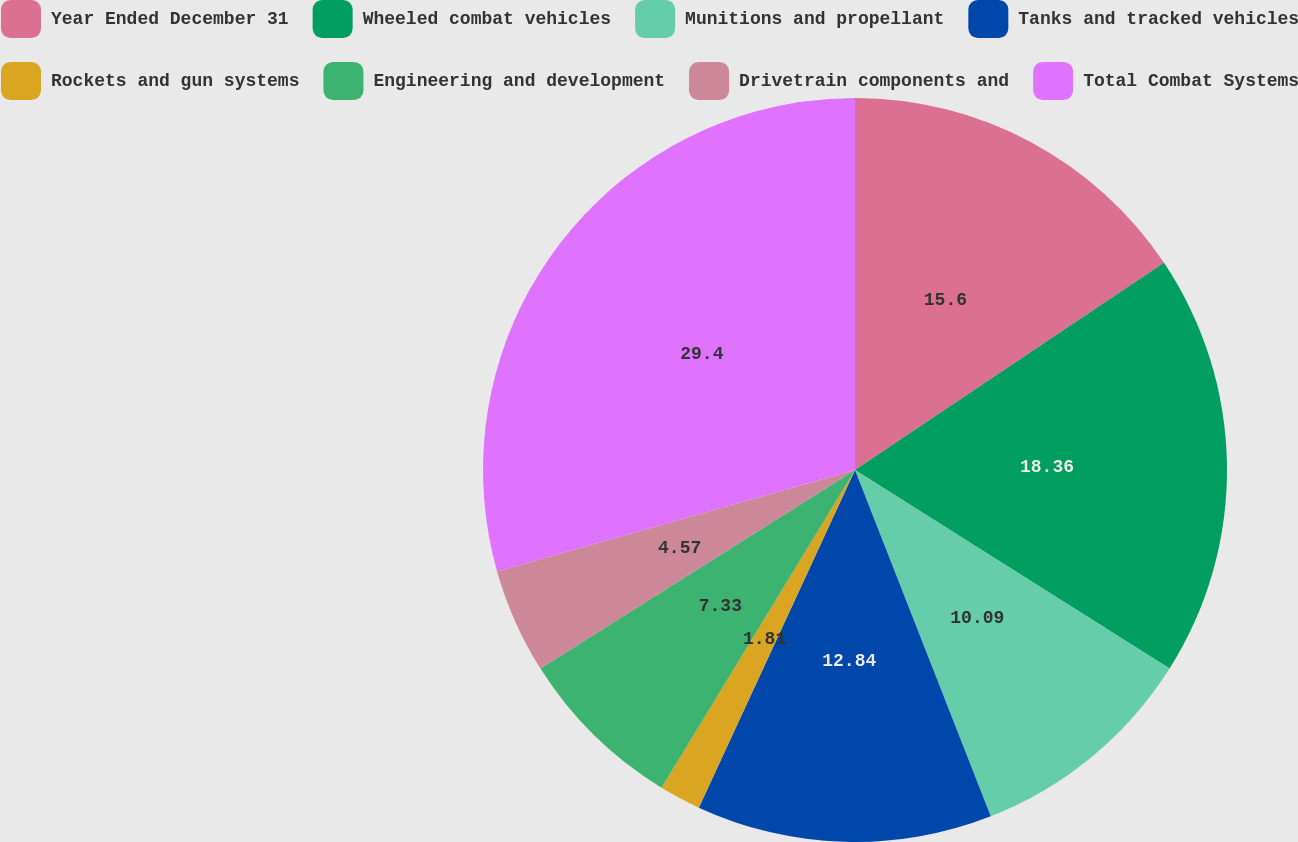Convert chart. <chart><loc_0><loc_0><loc_500><loc_500><pie_chart><fcel>Year Ended December 31<fcel>Wheeled combat vehicles<fcel>Munitions and propellant<fcel>Tanks and tracked vehicles<fcel>Rockets and gun systems<fcel>Engineering and development<fcel>Drivetrain components and<fcel>Total Combat Systems<nl><fcel>15.6%<fcel>18.36%<fcel>10.09%<fcel>12.84%<fcel>1.81%<fcel>7.33%<fcel>4.57%<fcel>29.39%<nl></chart> 